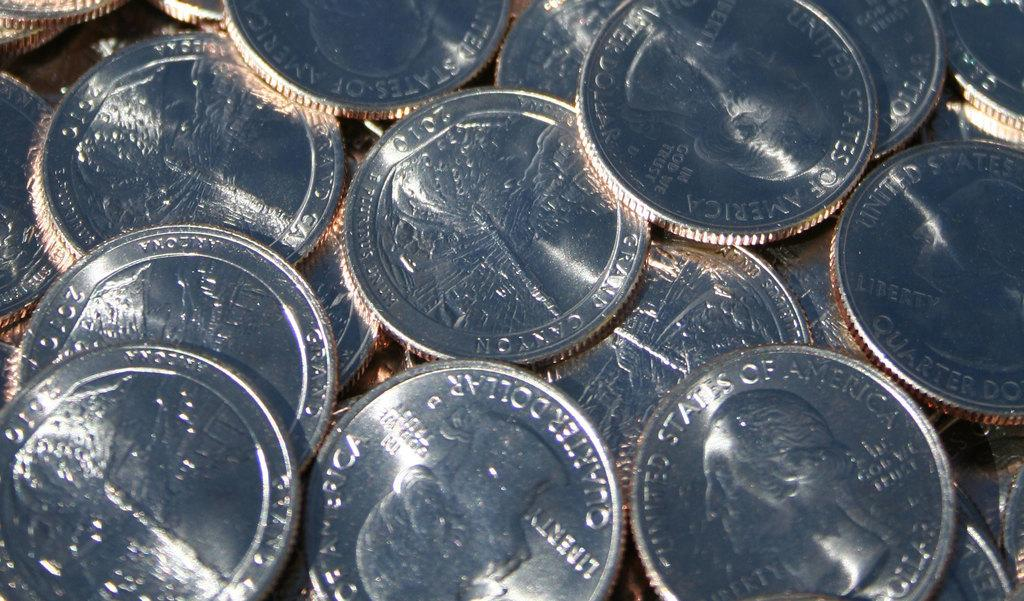<image>
Give a short and clear explanation of the subsequent image. A bunch of quarters featuring President George Washington are spread out. 